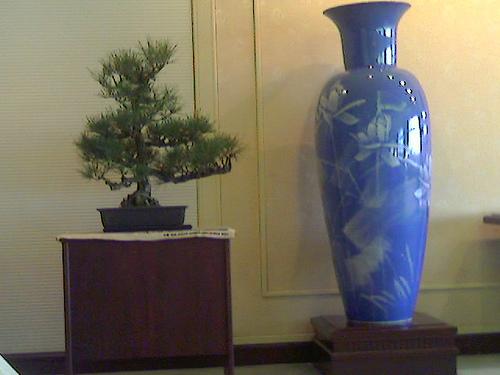What color is the vase?
Concise answer only. Blue. What is behind the vase?
Quick response, please. Wall. Is the vase taller than the bonsai tree?
Be succinct. Yes. What is the vase sitting on?
Give a very brief answer. Pedestal. What is the object near the vase?
Concise answer only. Bonsai tree. 